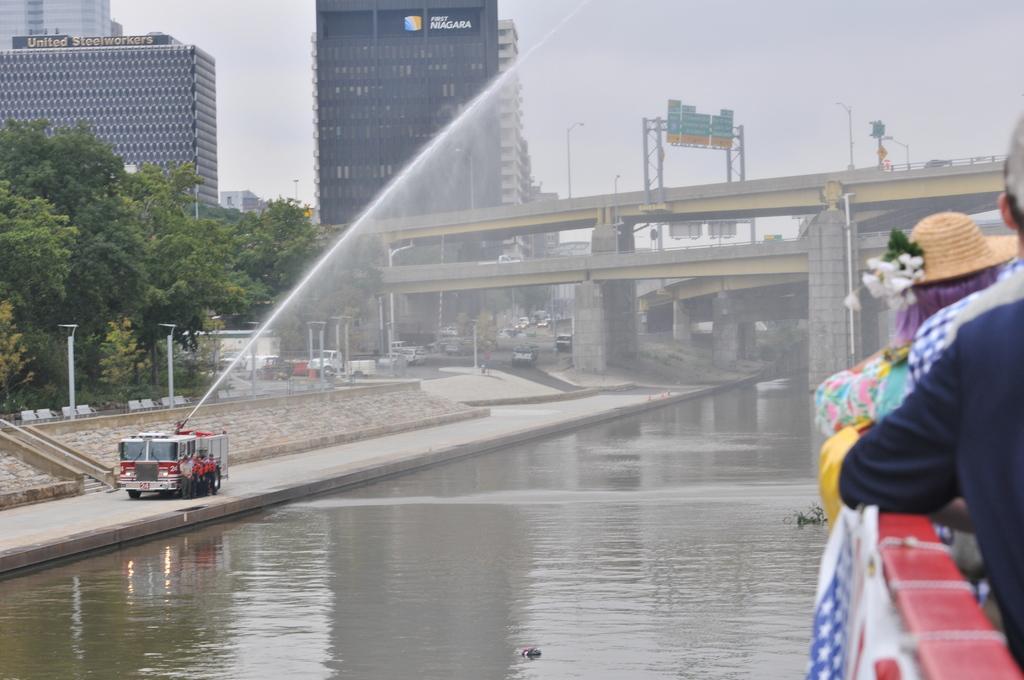Can you describe this image briefly? In this image there are buildings, there is text on the building, there are bridges, there are boards, there is text on the board, there are poles, there are street lights, there are vehicles, there is water, there is a fire engine, there are persons standing, there are trees towards the left of the image, there is a flag towards the bottom of the image, there is an object towards the bottom of the image, there are group of persons standing towards the right of the image. 